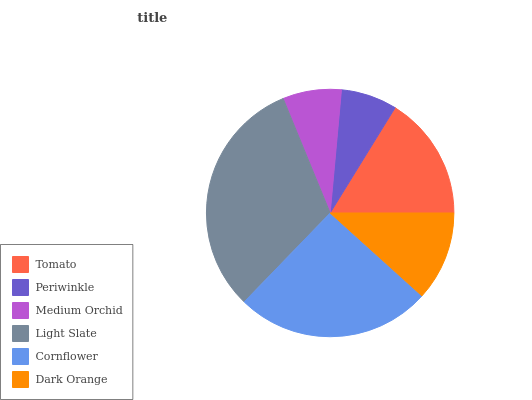Is Periwinkle the minimum?
Answer yes or no. Yes. Is Light Slate the maximum?
Answer yes or no. Yes. Is Medium Orchid the minimum?
Answer yes or no. No. Is Medium Orchid the maximum?
Answer yes or no. No. Is Medium Orchid greater than Periwinkle?
Answer yes or no. Yes. Is Periwinkle less than Medium Orchid?
Answer yes or no. Yes. Is Periwinkle greater than Medium Orchid?
Answer yes or no. No. Is Medium Orchid less than Periwinkle?
Answer yes or no. No. Is Tomato the high median?
Answer yes or no. Yes. Is Dark Orange the low median?
Answer yes or no. Yes. Is Dark Orange the high median?
Answer yes or no. No. Is Cornflower the low median?
Answer yes or no. No. 